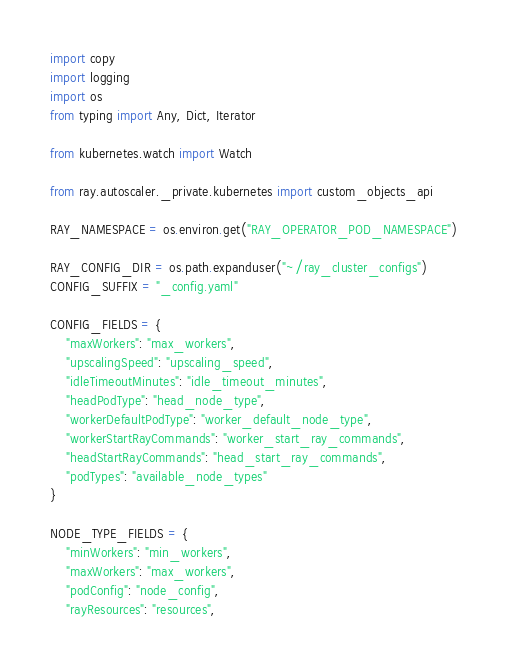Convert code to text. <code><loc_0><loc_0><loc_500><loc_500><_Python_>import copy
import logging
import os
from typing import Any, Dict, Iterator

from kubernetes.watch import Watch

from ray.autoscaler._private.kubernetes import custom_objects_api

RAY_NAMESPACE = os.environ.get("RAY_OPERATOR_POD_NAMESPACE")

RAY_CONFIG_DIR = os.path.expanduser("~/ray_cluster_configs")
CONFIG_SUFFIX = "_config.yaml"

CONFIG_FIELDS = {
    "maxWorkers": "max_workers",
    "upscalingSpeed": "upscaling_speed",
    "idleTimeoutMinutes": "idle_timeout_minutes",
    "headPodType": "head_node_type",
    "workerDefaultPodType": "worker_default_node_type",
    "workerStartRayCommands": "worker_start_ray_commands",
    "headStartRayCommands": "head_start_ray_commands",
    "podTypes": "available_node_types"
}

NODE_TYPE_FIELDS = {
    "minWorkers": "min_workers",
    "maxWorkers": "max_workers",
    "podConfig": "node_config",
    "rayResources": "resources",</code> 